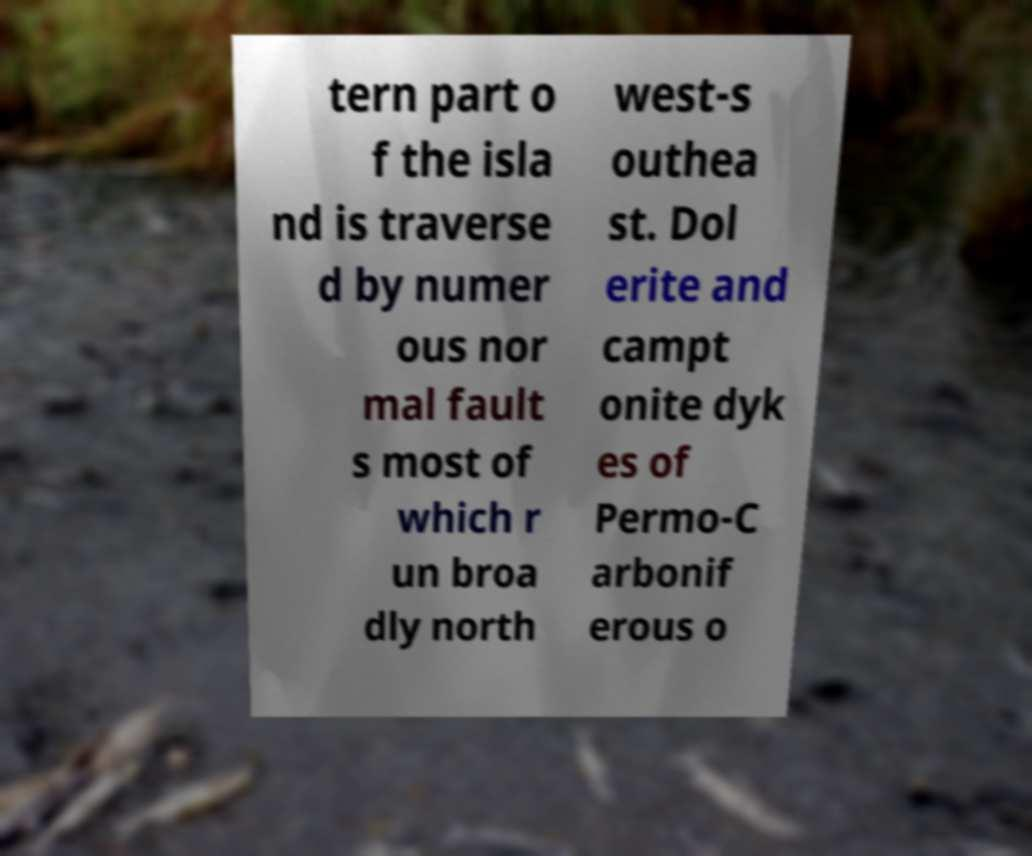Please identify and transcribe the text found in this image. tern part o f the isla nd is traverse d by numer ous nor mal fault s most of which r un broa dly north west-s outhea st. Dol erite and campt onite dyk es of Permo-C arbonif erous o 